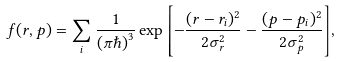<formula> <loc_0><loc_0><loc_500><loc_500>f ( r , p ) = \sum _ { i } { \frac { 1 } { ( \pi \hbar { ) } ^ { 3 } } \exp \left [ - \frac { ( r - r _ { i } ) ^ { 2 } } { 2 \sigma _ { r } ^ { 2 } } - \frac { ( p - p _ { i } ) ^ { 2 } } { 2 \sigma _ { p } ^ { 2 } } \right ] } ,</formula> 